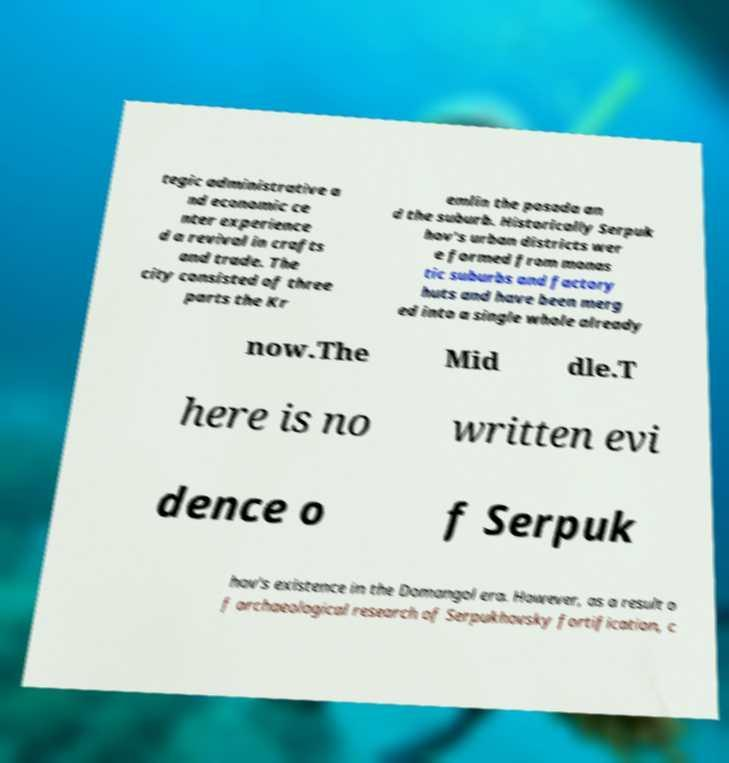Could you extract and type out the text from this image? tegic administrative a nd economic ce nter experience d a revival in crafts and trade. The city consisted of three parts the Kr emlin the posada an d the suburb. Historically Serpuk hov's urban districts wer e formed from monas tic suburbs and factory huts and have been merg ed into a single whole already now.The Mid dle.T here is no written evi dence o f Serpuk hov's existence in the Domangol era. However, as a result o f archaeological research of Serpukhovsky fortification, c 